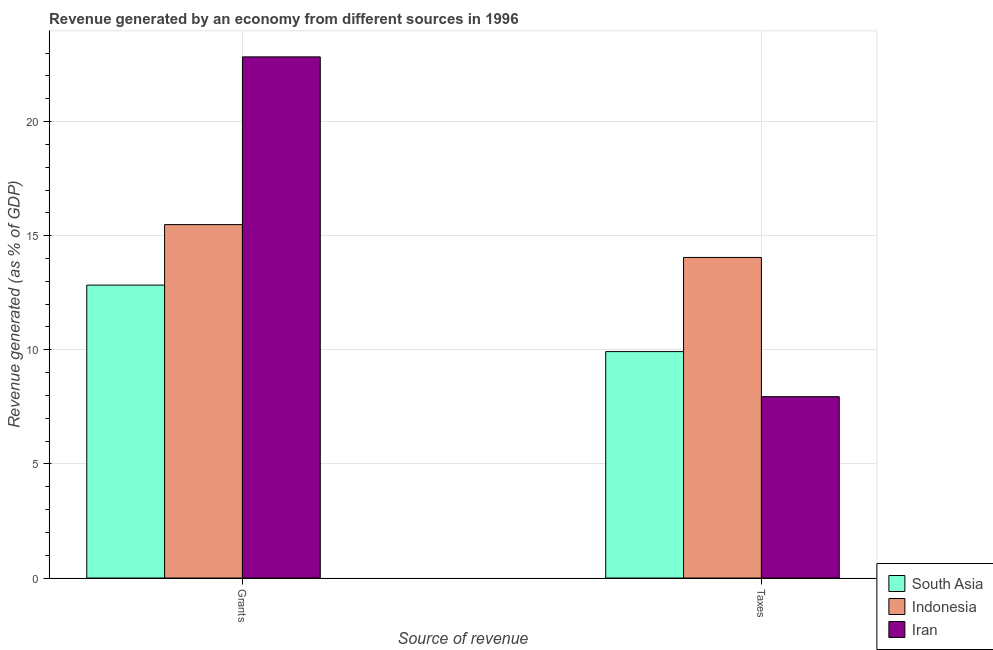How many different coloured bars are there?
Your response must be concise. 3. How many bars are there on the 1st tick from the left?
Provide a short and direct response. 3. How many bars are there on the 2nd tick from the right?
Offer a terse response. 3. What is the label of the 1st group of bars from the left?
Give a very brief answer. Grants. What is the revenue generated by taxes in Iran?
Provide a short and direct response. 7.95. Across all countries, what is the maximum revenue generated by taxes?
Your answer should be very brief. 14.05. Across all countries, what is the minimum revenue generated by grants?
Offer a very short reply. 12.84. In which country was the revenue generated by grants maximum?
Keep it short and to the point. Iran. What is the total revenue generated by taxes in the graph?
Offer a terse response. 31.92. What is the difference between the revenue generated by taxes in Indonesia and that in Iran?
Give a very brief answer. 6.1. What is the difference between the revenue generated by taxes in Indonesia and the revenue generated by grants in South Asia?
Give a very brief answer. 1.21. What is the average revenue generated by taxes per country?
Ensure brevity in your answer.  10.64. What is the difference between the revenue generated by grants and revenue generated by taxes in Indonesia?
Your response must be concise. 1.44. What is the ratio of the revenue generated by taxes in Indonesia to that in South Asia?
Your response must be concise. 1.42. Is the revenue generated by grants in Indonesia less than that in South Asia?
Offer a terse response. No. In how many countries, is the revenue generated by grants greater than the average revenue generated by grants taken over all countries?
Provide a short and direct response. 1. What does the 1st bar from the left in Taxes represents?
Provide a short and direct response. South Asia. What does the 2nd bar from the right in Grants represents?
Make the answer very short. Indonesia. What is the difference between two consecutive major ticks on the Y-axis?
Your response must be concise. 5. Are the values on the major ticks of Y-axis written in scientific E-notation?
Offer a terse response. No. Does the graph contain grids?
Keep it short and to the point. Yes. Where does the legend appear in the graph?
Your answer should be compact. Bottom right. How many legend labels are there?
Provide a short and direct response. 3. What is the title of the graph?
Keep it short and to the point. Revenue generated by an economy from different sources in 1996. What is the label or title of the X-axis?
Make the answer very short. Source of revenue. What is the label or title of the Y-axis?
Keep it short and to the point. Revenue generated (as % of GDP). What is the Revenue generated (as % of GDP) of South Asia in Grants?
Your response must be concise. 12.84. What is the Revenue generated (as % of GDP) in Indonesia in Grants?
Your response must be concise. 15.49. What is the Revenue generated (as % of GDP) in Iran in Grants?
Your answer should be very brief. 22.84. What is the Revenue generated (as % of GDP) in South Asia in Taxes?
Offer a very short reply. 9.92. What is the Revenue generated (as % of GDP) of Indonesia in Taxes?
Give a very brief answer. 14.05. What is the Revenue generated (as % of GDP) in Iran in Taxes?
Your answer should be very brief. 7.95. Across all Source of revenue, what is the maximum Revenue generated (as % of GDP) of South Asia?
Your response must be concise. 12.84. Across all Source of revenue, what is the maximum Revenue generated (as % of GDP) of Indonesia?
Make the answer very short. 15.49. Across all Source of revenue, what is the maximum Revenue generated (as % of GDP) in Iran?
Make the answer very short. 22.84. Across all Source of revenue, what is the minimum Revenue generated (as % of GDP) of South Asia?
Provide a short and direct response. 9.92. Across all Source of revenue, what is the minimum Revenue generated (as % of GDP) of Indonesia?
Give a very brief answer. 14.05. Across all Source of revenue, what is the minimum Revenue generated (as % of GDP) in Iran?
Make the answer very short. 7.95. What is the total Revenue generated (as % of GDP) in South Asia in the graph?
Keep it short and to the point. 22.76. What is the total Revenue generated (as % of GDP) in Indonesia in the graph?
Make the answer very short. 29.53. What is the total Revenue generated (as % of GDP) in Iran in the graph?
Keep it short and to the point. 30.78. What is the difference between the Revenue generated (as % of GDP) of South Asia in Grants and that in Taxes?
Provide a short and direct response. 2.91. What is the difference between the Revenue generated (as % of GDP) of Indonesia in Grants and that in Taxes?
Offer a very short reply. 1.44. What is the difference between the Revenue generated (as % of GDP) in Iran in Grants and that in Taxes?
Keep it short and to the point. 14.89. What is the difference between the Revenue generated (as % of GDP) in South Asia in Grants and the Revenue generated (as % of GDP) in Indonesia in Taxes?
Your answer should be compact. -1.21. What is the difference between the Revenue generated (as % of GDP) of South Asia in Grants and the Revenue generated (as % of GDP) of Iran in Taxes?
Make the answer very short. 4.89. What is the difference between the Revenue generated (as % of GDP) in Indonesia in Grants and the Revenue generated (as % of GDP) in Iran in Taxes?
Keep it short and to the point. 7.54. What is the average Revenue generated (as % of GDP) of South Asia per Source of revenue?
Ensure brevity in your answer.  11.38. What is the average Revenue generated (as % of GDP) in Indonesia per Source of revenue?
Your answer should be compact. 14.77. What is the average Revenue generated (as % of GDP) of Iran per Source of revenue?
Ensure brevity in your answer.  15.39. What is the difference between the Revenue generated (as % of GDP) of South Asia and Revenue generated (as % of GDP) of Indonesia in Grants?
Keep it short and to the point. -2.65. What is the difference between the Revenue generated (as % of GDP) of South Asia and Revenue generated (as % of GDP) of Iran in Grants?
Keep it short and to the point. -10. What is the difference between the Revenue generated (as % of GDP) in Indonesia and Revenue generated (as % of GDP) in Iran in Grants?
Provide a short and direct response. -7.35. What is the difference between the Revenue generated (as % of GDP) in South Asia and Revenue generated (as % of GDP) in Indonesia in Taxes?
Your answer should be compact. -4.13. What is the difference between the Revenue generated (as % of GDP) of South Asia and Revenue generated (as % of GDP) of Iran in Taxes?
Keep it short and to the point. 1.98. What is the difference between the Revenue generated (as % of GDP) in Indonesia and Revenue generated (as % of GDP) in Iran in Taxes?
Offer a terse response. 6.1. What is the ratio of the Revenue generated (as % of GDP) of South Asia in Grants to that in Taxes?
Give a very brief answer. 1.29. What is the ratio of the Revenue generated (as % of GDP) of Indonesia in Grants to that in Taxes?
Your response must be concise. 1.1. What is the ratio of the Revenue generated (as % of GDP) of Iran in Grants to that in Taxes?
Provide a short and direct response. 2.87. What is the difference between the highest and the second highest Revenue generated (as % of GDP) in South Asia?
Offer a terse response. 2.91. What is the difference between the highest and the second highest Revenue generated (as % of GDP) in Indonesia?
Offer a terse response. 1.44. What is the difference between the highest and the second highest Revenue generated (as % of GDP) of Iran?
Make the answer very short. 14.89. What is the difference between the highest and the lowest Revenue generated (as % of GDP) in South Asia?
Your answer should be very brief. 2.91. What is the difference between the highest and the lowest Revenue generated (as % of GDP) in Indonesia?
Your answer should be very brief. 1.44. What is the difference between the highest and the lowest Revenue generated (as % of GDP) of Iran?
Your answer should be compact. 14.89. 